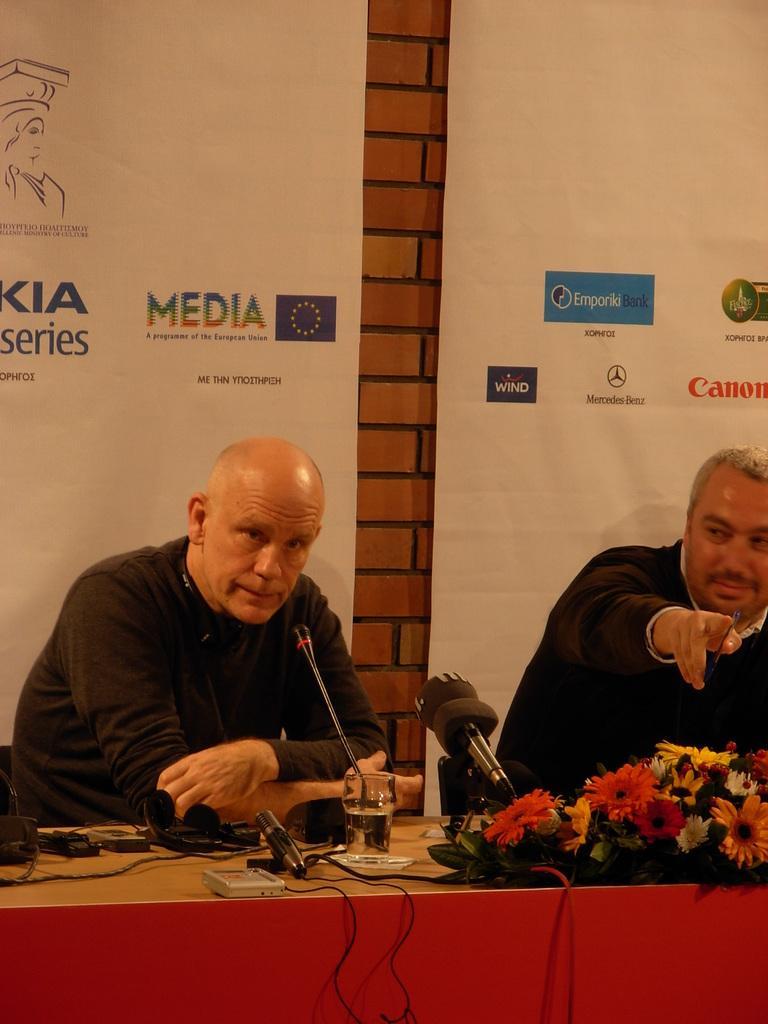Describe this image in one or two sentences. In this picture we can see two persons are sitting on the chairs. And this is the table, and there are some flowers on the table. On the background there is a brick wall. And these are the banners. 